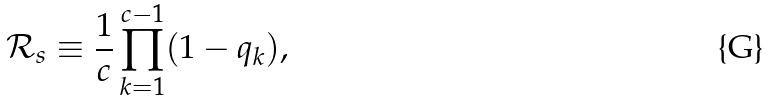<formula> <loc_0><loc_0><loc_500><loc_500>\mathcal { R } _ { s } \equiv \frac { 1 } { c } \prod _ { k = 1 } ^ { c - 1 } ( 1 - q _ { k } ) ,</formula> 